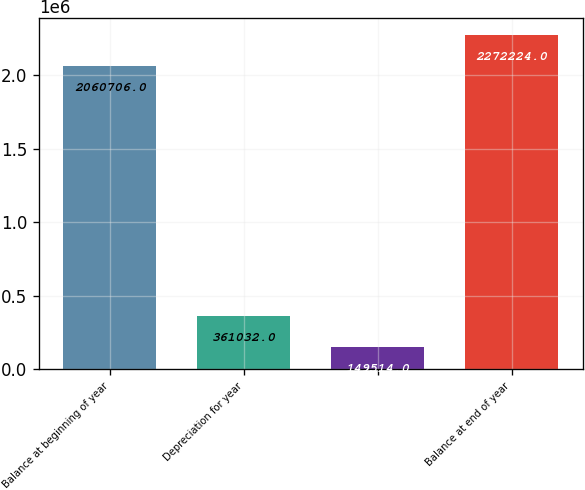<chart> <loc_0><loc_0><loc_500><loc_500><bar_chart><fcel>Balance at beginning of year<fcel>Depreciation for year<fcel>Unnamed: 2<fcel>Balance at end of year<nl><fcel>2.06071e+06<fcel>361032<fcel>149514<fcel>2.27222e+06<nl></chart> 